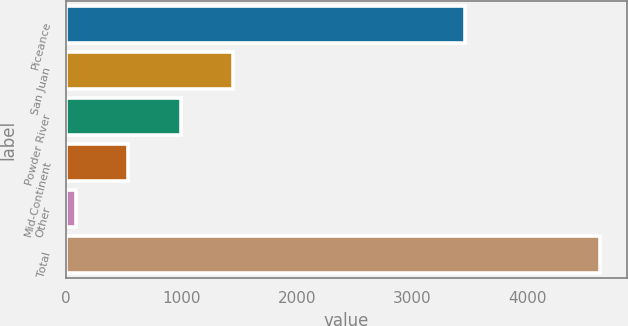Convert chart. <chart><loc_0><loc_0><loc_500><loc_500><bar_chart><fcel>Piceance<fcel>San Juan<fcel>Powder River<fcel>Mid-Continent<fcel>Other<fcel>Total<nl><fcel>3455<fcel>1449.1<fcel>994.4<fcel>539.7<fcel>85<fcel>4632<nl></chart> 